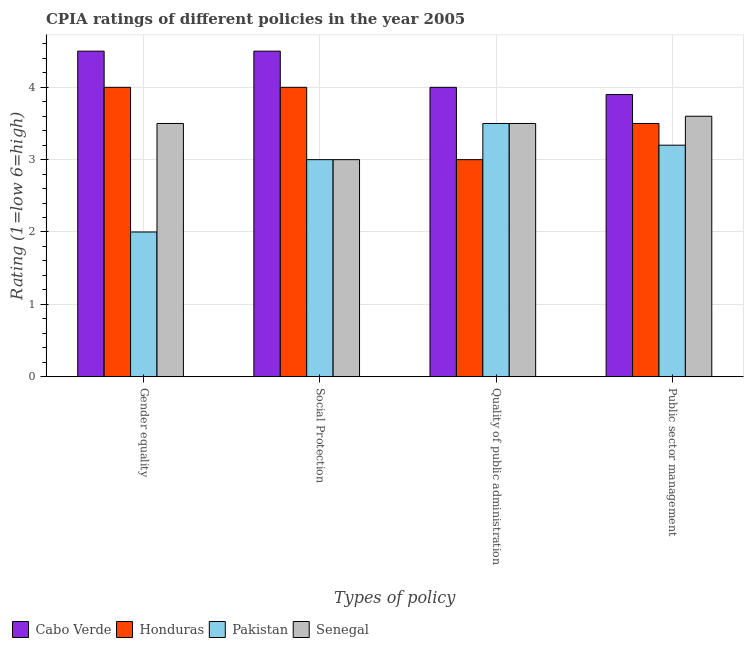How many different coloured bars are there?
Your response must be concise. 4. How many groups of bars are there?
Give a very brief answer. 4. Are the number of bars on each tick of the X-axis equal?
Provide a succinct answer. Yes. What is the label of the 1st group of bars from the left?
Offer a very short reply. Gender equality. Across all countries, what is the minimum cpia rating of public sector management?
Provide a succinct answer. 3.2. In which country was the cpia rating of social protection maximum?
Your response must be concise. Cabo Verde. In which country was the cpia rating of quality of public administration minimum?
Keep it short and to the point. Honduras. What is the total cpia rating of social protection in the graph?
Provide a succinct answer. 14.5. What is the difference between the cpia rating of gender equality in Honduras and that in Senegal?
Give a very brief answer. 0.5. What is the difference between the cpia rating of quality of public administration in Pakistan and the cpia rating of public sector management in Senegal?
Ensure brevity in your answer.  -0.1. What is the difference between the cpia rating of quality of public administration and cpia rating of public sector management in Senegal?
Your answer should be compact. -0.1. In how many countries, is the cpia rating of gender equality greater than 4.4 ?
Make the answer very short. 1. Is the difference between the cpia rating of social protection in Senegal and Pakistan greater than the difference between the cpia rating of public sector management in Senegal and Pakistan?
Your answer should be very brief. No. Is it the case that in every country, the sum of the cpia rating of social protection and cpia rating of public sector management is greater than the sum of cpia rating of gender equality and cpia rating of quality of public administration?
Make the answer very short. No. What does the 3rd bar from the right in Gender equality represents?
Your answer should be very brief. Honduras. Is it the case that in every country, the sum of the cpia rating of gender equality and cpia rating of social protection is greater than the cpia rating of quality of public administration?
Your answer should be compact. Yes. How many bars are there?
Your answer should be compact. 16. How many countries are there in the graph?
Give a very brief answer. 4. What is the difference between two consecutive major ticks on the Y-axis?
Make the answer very short. 1. Does the graph contain any zero values?
Offer a very short reply. No. Does the graph contain grids?
Keep it short and to the point. Yes. Where does the legend appear in the graph?
Give a very brief answer. Bottom left. What is the title of the graph?
Give a very brief answer. CPIA ratings of different policies in the year 2005. What is the label or title of the X-axis?
Provide a short and direct response. Types of policy. What is the Rating (1=low 6=high) of Pakistan in Gender equality?
Provide a succinct answer. 2. What is the Rating (1=low 6=high) in Pakistan in Social Protection?
Offer a terse response. 3. What is the Rating (1=low 6=high) in Senegal in Social Protection?
Provide a short and direct response. 3. What is the Rating (1=low 6=high) of Pakistan in Quality of public administration?
Provide a short and direct response. 3.5. What is the Rating (1=low 6=high) of Senegal in Quality of public administration?
Your answer should be compact. 3.5. What is the Rating (1=low 6=high) of Honduras in Public sector management?
Offer a terse response. 3.5. Across all Types of policy, what is the maximum Rating (1=low 6=high) in Cabo Verde?
Offer a terse response. 4.5. Across all Types of policy, what is the minimum Rating (1=low 6=high) in Pakistan?
Keep it short and to the point. 2. Across all Types of policy, what is the minimum Rating (1=low 6=high) in Senegal?
Your answer should be compact. 3. What is the total Rating (1=low 6=high) in Cabo Verde in the graph?
Provide a succinct answer. 16.9. What is the total Rating (1=low 6=high) of Honduras in the graph?
Provide a short and direct response. 14.5. What is the total Rating (1=low 6=high) of Pakistan in the graph?
Provide a succinct answer. 11.7. What is the total Rating (1=low 6=high) of Senegal in the graph?
Offer a very short reply. 13.6. What is the difference between the Rating (1=low 6=high) in Honduras in Gender equality and that in Social Protection?
Provide a short and direct response. 0. What is the difference between the Rating (1=low 6=high) of Pakistan in Gender equality and that in Social Protection?
Ensure brevity in your answer.  -1. What is the difference between the Rating (1=low 6=high) of Honduras in Gender equality and that in Quality of public administration?
Provide a succinct answer. 1. What is the difference between the Rating (1=low 6=high) of Pakistan in Gender equality and that in Quality of public administration?
Keep it short and to the point. -1.5. What is the difference between the Rating (1=low 6=high) of Senegal in Gender equality and that in Quality of public administration?
Keep it short and to the point. 0. What is the difference between the Rating (1=low 6=high) in Cabo Verde in Gender equality and that in Public sector management?
Keep it short and to the point. 0.6. What is the difference between the Rating (1=low 6=high) in Pakistan in Social Protection and that in Quality of public administration?
Make the answer very short. -0.5. What is the difference between the Rating (1=low 6=high) of Senegal in Social Protection and that in Quality of public administration?
Provide a succinct answer. -0.5. What is the difference between the Rating (1=low 6=high) of Cabo Verde in Social Protection and that in Public sector management?
Offer a very short reply. 0.6. What is the difference between the Rating (1=low 6=high) in Pakistan in Social Protection and that in Public sector management?
Provide a short and direct response. -0.2. What is the difference between the Rating (1=low 6=high) of Senegal in Social Protection and that in Public sector management?
Your answer should be compact. -0.6. What is the difference between the Rating (1=low 6=high) of Honduras in Quality of public administration and that in Public sector management?
Your answer should be compact. -0.5. What is the difference between the Rating (1=low 6=high) in Cabo Verde in Gender equality and the Rating (1=low 6=high) in Honduras in Social Protection?
Offer a terse response. 0.5. What is the difference between the Rating (1=low 6=high) of Cabo Verde in Gender equality and the Rating (1=low 6=high) of Senegal in Social Protection?
Provide a succinct answer. 1.5. What is the difference between the Rating (1=low 6=high) of Honduras in Gender equality and the Rating (1=low 6=high) of Senegal in Social Protection?
Ensure brevity in your answer.  1. What is the difference between the Rating (1=low 6=high) of Cabo Verde in Gender equality and the Rating (1=low 6=high) of Honduras in Quality of public administration?
Ensure brevity in your answer.  1.5. What is the difference between the Rating (1=low 6=high) in Cabo Verde in Gender equality and the Rating (1=low 6=high) in Pakistan in Quality of public administration?
Ensure brevity in your answer.  1. What is the difference between the Rating (1=low 6=high) of Honduras in Gender equality and the Rating (1=low 6=high) of Senegal in Quality of public administration?
Offer a terse response. 0.5. What is the difference between the Rating (1=low 6=high) in Cabo Verde in Gender equality and the Rating (1=low 6=high) in Honduras in Public sector management?
Offer a very short reply. 1. What is the difference between the Rating (1=low 6=high) of Cabo Verde in Gender equality and the Rating (1=low 6=high) of Senegal in Public sector management?
Ensure brevity in your answer.  0.9. What is the difference between the Rating (1=low 6=high) of Honduras in Gender equality and the Rating (1=low 6=high) of Senegal in Public sector management?
Offer a terse response. 0.4. What is the difference between the Rating (1=low 6=high) of Honduras in Social Protection and the Rating (1=low 6=high) of Senegal in Quality of public administration?
Keep it short and to the point. 0.5. What is the difference between the Rating (1=low 6=high) of Pakistan in Social Protection and the Rating (1=low 6=high) of Senegal in Quality of public administration?
Make the answer very short. -0.5. What is the difference between the Rating (1=low 6=high) of Cabo Verde in Social Protection and the Rating (1=low 6=high) of Pakistan in Public sector management?
Offer a very short reply. 1.3. What is the difference between the Rating (1=low 6=high) in Honduras in Social Protection and the Rating (1=low 6=high) in Pakistan in Public sector management?
Offer a very short reply. 0.8. What is the difference between the Rating (1=low 6=high) in Honduras in Social Protection and the Rating (1=low 6=high) in Senegal in Public sector management?
Ensure brevity in your answer.  0.4. What is the difference between the Rating (1=low 6=high) in Cabo Verde in Quality of public administration and the Rating (1=low 6=high) in Honduras in Public sector management?
Provide a short and direct response. 0.5. What is the difference between the Rating (1=low 6=high) of Cabo Verde in Quality of public administration and the Rating (1=low 6=high) of Pakistan in Public sector management?
Make the answer very short. 0.8. What is the difference between the Rating (1=low 6=high) in Pakistan in Quality of public administration and the Rating (1=low 6=high) in Senegal in Public sector management?
Your answer should be very brief. -0.1. What is the average Rating (1=low 6=high) in Cabo Verde per Types of policy?
Provide a short and direct response. 4.22. What is the average Rating (1=low 6=high) of Honduras per Types of policy?
Offer a very short reply. 3.62. What is the average Rating (1=low 6=high) of Pakistan per Types of policy?
Give a very brief answer. 2.92. What is the difference between the Rating (1=low 6=high) of Cabo Verde and Rating (1=low 6=high) of Pakistan in Gender equality?
Your answer should be very brief. 2.5. What is the difference between the Rating (1=low 6=high) of Pakistan and Rating (1=low 6=high) of Senegal in Gender equality?
Give a very brief answer. -1.5. What is the difference between the Rating (1=low 6=high) in Cabo Verde and Rating (1=low 6=high) in Senegal in Social Protection?
Your answer should be compact. 1.5. What is the difference between the Rating (1=low 6=high) in Honduras and Rating (1=low 6=high) in Senegal in Social Protection?
Provide a short and direct response. 1. What is the difference between the Rating (1=low 6=high) in Pakistan and Rating (1=low 6=high) in Senegal in Social Protection?
Give a very brief answer. 0. What is the difference between the Rating (1=low 6=high) in Cabo Verde and Rating (1=low 6=high) in Honduras in Quality of public administration?
Offer a terse response. 1. What is the difference between the Rating (1=low 6=high) in Cabo Verde and Rating (1=low 6=high) in Senegal in Quality of public administration?
Keep it short and to the point. 0.5. What is the difference between the Rating (1=low 6=high) of Honduras and Rating (1=low 6=high) of Pakistan in Quality of public administration?
Make the answer very short. -0.5. What is the difference between the Rating (1=low 6=high) of Cabo Verde and Rating (1=low 6=high) of Senegal in Public sector management?
Your response must be concise. 0.3. What is the ratio of the Rating (1=low 6=high) in Cabo Verde in Gender equality to that in Social Protection?
Make the answer very short. 1. What is the ratio of the Rating (1=low 6=high) in Honduras in Gender equality to that in Social Protection?
Offer a terse response. 1. What is the ratio of the Rating (1=low 6=high) in Pakistan in Gender equality to that in Social Protection?
Your answer should be very brief. 0.67. What is the ratio of the Rating (1=low 6=high) in Senegal in Gender equality to that in Social Protection?
Your response must be concise. 1.17. What is the ratio of the Rating (1=low 6=high) of Pakistan in Gender equality to that in Quality of public administration?
Provide a short and direct response. 0.57. What is the ratio of the Rating (1=low 6=high) in Cabo Verde in Gender equality to that in Public sector management?
Make the answer very short. 1.15. What is the ratio of the Rating (1=low 6=high) of Pakistan in Gender equality to that in Public sector management?
Your answer should be very brief. 0.62. What is the ratio of the Rating (1=low 6=high) of Senegal in Gender equality to that in Public sector management?
Offer a very short reply. 0.97. What is the ratio of the Rating (1=low 6=high) in Cabo Verde in Social Protection to that in Public sector management?
Ensure brevity in your answer.  1.15. What is the ratio of the Rating (1=low 6=high) of Pakistan in Social Protection to that in Public sector management?
Offer a terse response. 0.94. What is the ratio of the Rating (1=low 6=high) of Senegal in Social Protection to that in Public sector management?
Keep it short and to the point. 0.83. What is the ratio of the Rating (1=low 6=high) in Cabo Verde in Quality of public administration to that in Public sector management?
Your answer should be compact. 1.03. What is the ratio of the Rating (1=low 6=high) in Pakistan in Quality of public administration to that in Public sector management?
Your answer should be compact. 1.09. What is the ratio of the Rating (1=low 6=high) in Senegal in Quality of public administration to that in Public sector management?
Your response must be concise. 0.97. What is the difference between the highest and the second highest Rating (1=low 6=high) in Honduras?
Give a very brief answer. 0. What is the difference between the highest and the second highest Rating (1=low 6=high) in Senegal?
Your answer should be very brief. 0.1. What is the difference between the highest and the lowest Rating (1=low 6=high) of Cabo Verde?
Keep it short and to the point. 0.6. What is the difference between the highest and the lowest Rating (1=low 6=high) in Honduras?
Your answer should be compact. 1. What is the difference between the highest and the lowest Rating (1=low 6=high) in Pakistan?
Your answer should be very brief. 1.5. What is the difference between the highest and the lowest Rating (1=low 6=high) of Senegal?
Offer a very short reply. 0.6. 